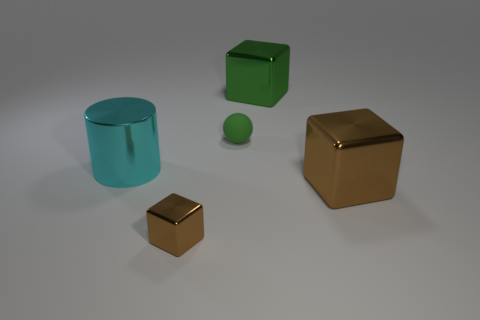Add 3 tiny green spheres. How many objects exist? 8 Subtract all spheres. How many objects are left? 4 Subtract all tiny green rubber balls. Subtract all small brown cubes. How many objects are left? 3 Add 3 green metal blocks. How many green metal blocks are left? 4 Add 4 small yellow rubber things. How many small yellow rubber things exist? 4 Subtract 1 cyan cylinders. How many objects are left? 4 